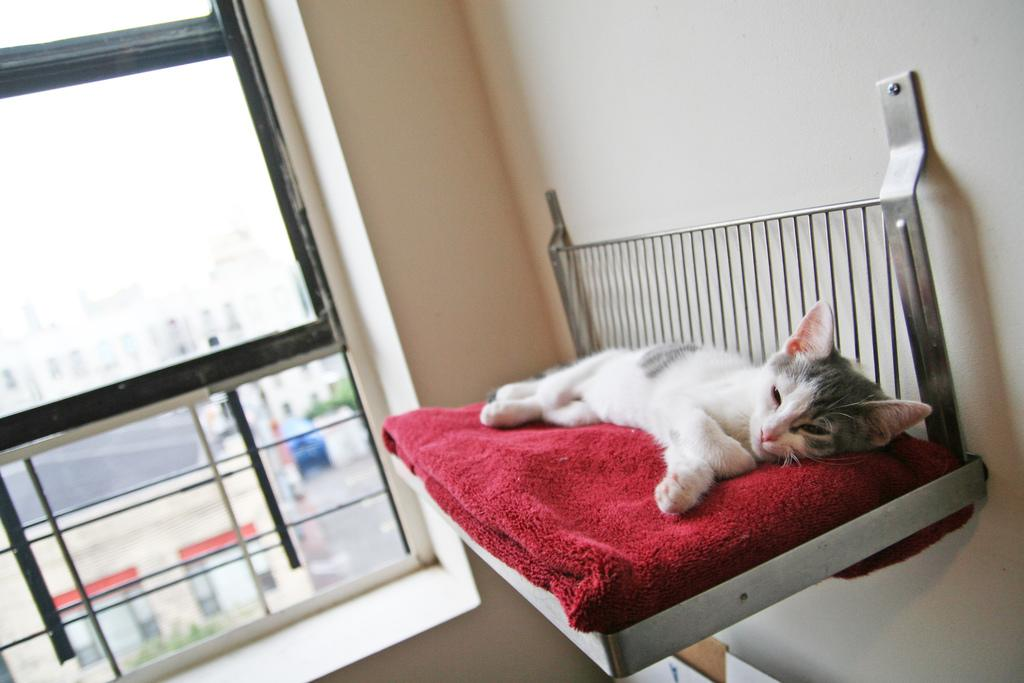What is: What type of structure is present in the image? There is a house in the image. What animal can be seen in the image? There is a cat in the image. What is the cat doing in the image? The cat is sleeping. What is the cat resting on in the image? The cat is on a red color cloth. What language is the cat speaking in the image? Cats do not speak human languages, so there is no language spoken by the cat in the image. 